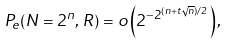<formula> <loc_0><loc_0><loc_500><loc_500>P _ { e } ( N = 2 ^ { n } , \, R ) = o \left ( 2 ^ { - 2 ^ { ( n + t \sqrt { n } ) / 2 } } \right ) ,</formula> 